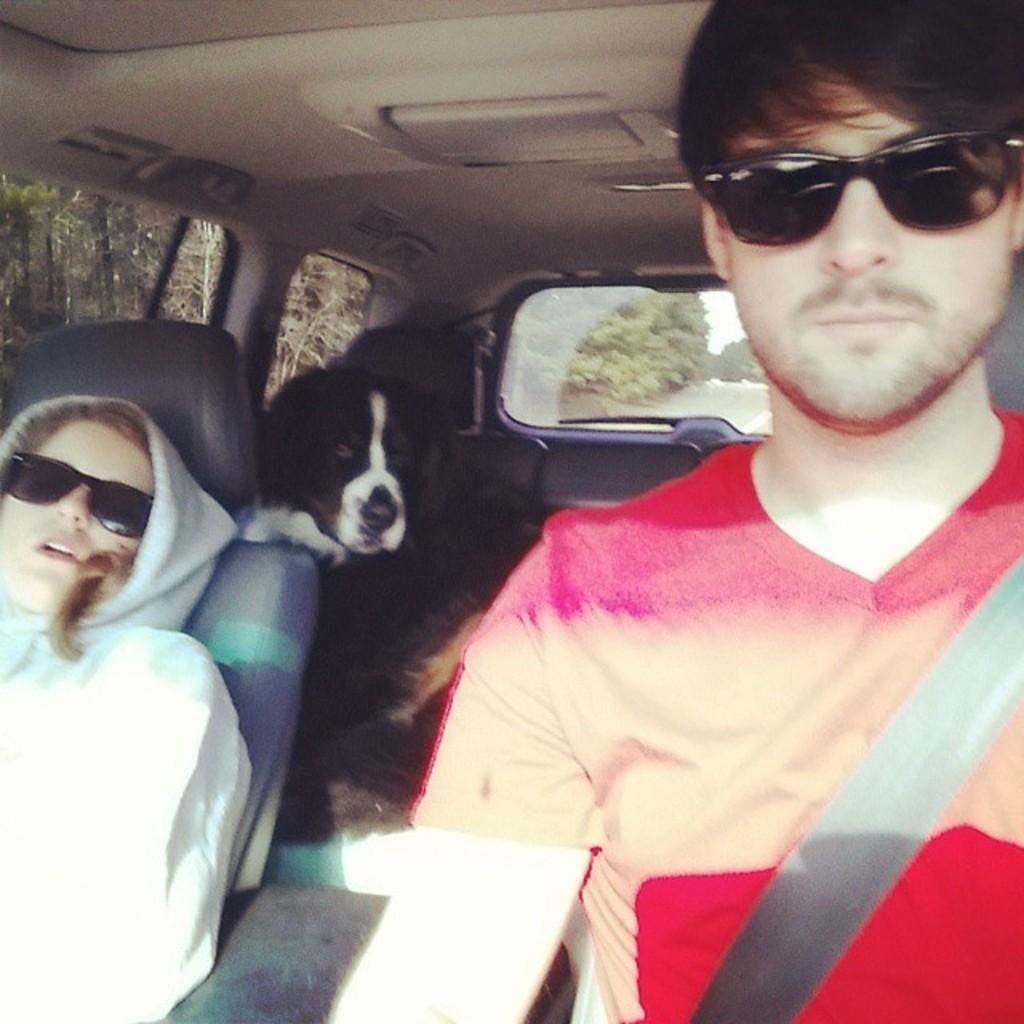What are the people in the image doing? The people in the image are sitting. What safety measure are the people using while sitting? The people are wearing seat belts. What animal is present in the image? There is a dog in the image. What is the color of the dog in the image? The dog is black in color. What type of quill is the dog using to write in the image? There is no quill present in the image, and the dog is not writing. 